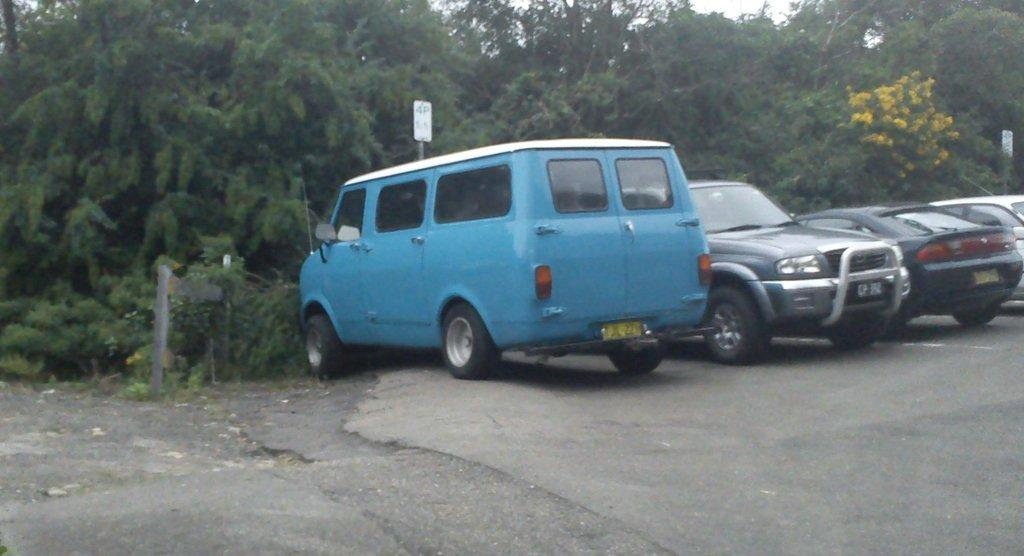What can be seen on the road in the image? There are vehicles parked on the road in the image. What is visible in the background of the image? Trees, flowers, and boards with poles are visible in the background of the image. What type of butter is being discussed in the image? There is no discussion or butter present in the image. Where is the field located in the image? There is no field present in the image. 